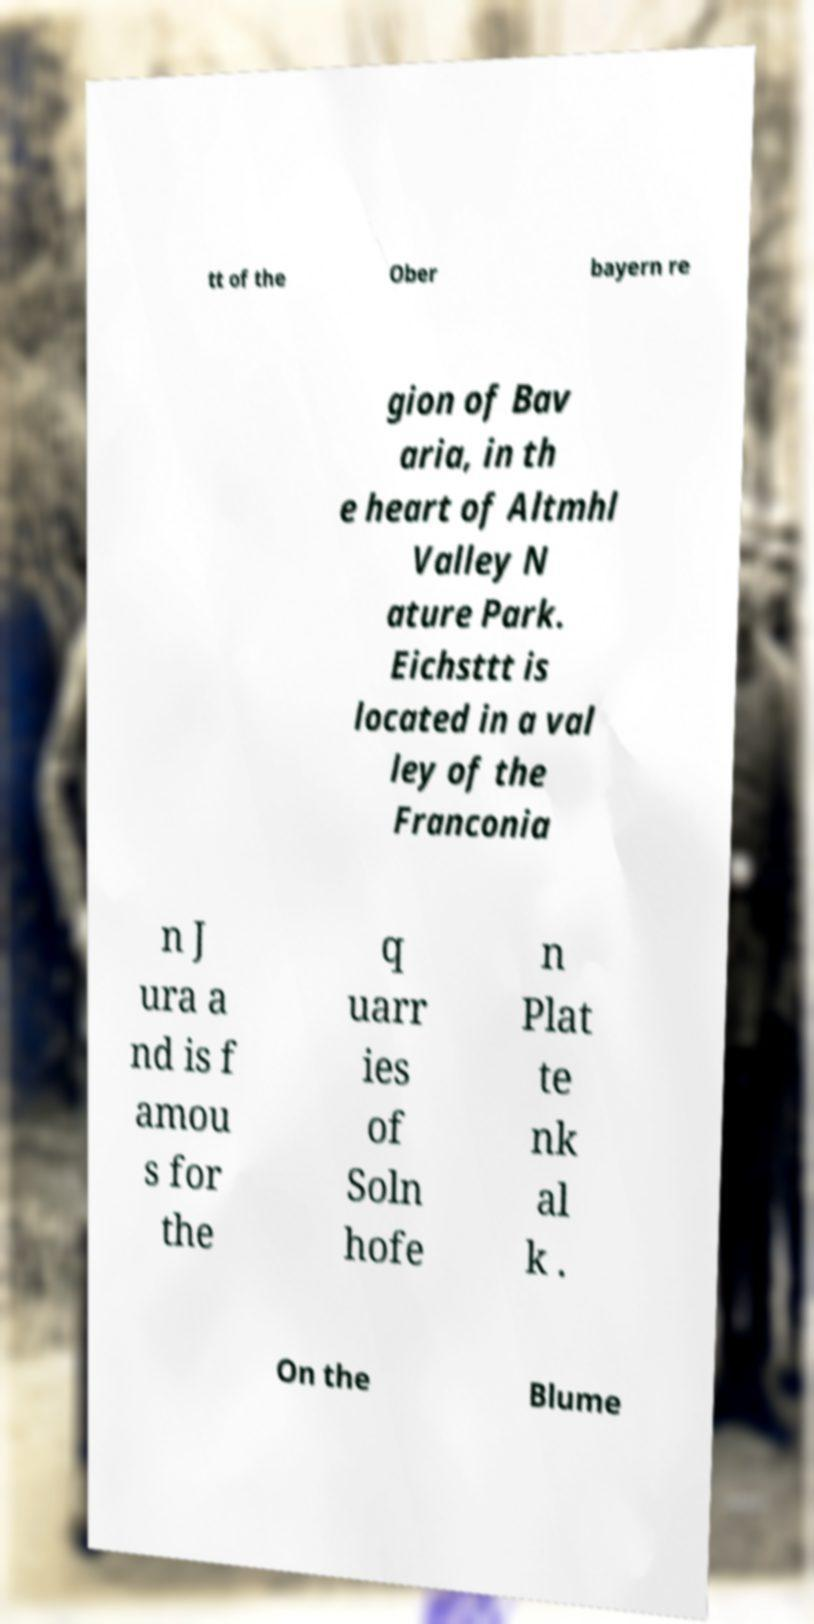Can you read and provide the text displayed in the image?This photo seems to have some interesting text. Can you extract and type it out for me? tt of the Ober bayern re gion of Bav aria, in th e heart of Altmhl Valley N ature Park. Eichsttt is located in a val ley of the Franconia n J ura a nd is f amou s for the q uarr ies of Soln hofe n Plat te nk al k . On the Blume 